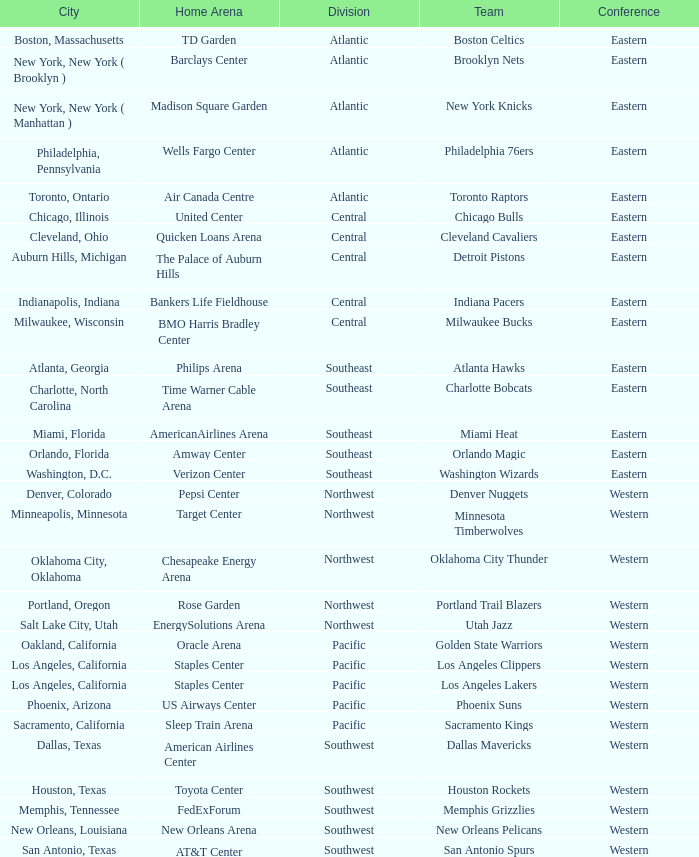Which city includes Barclays Center? New York, New York ( Brooklyn ). 